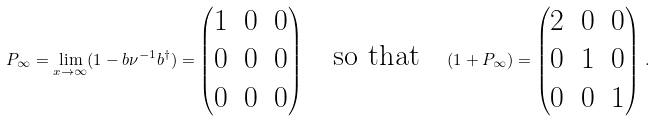<formula> <loc_0><loc_0><loc_500><loc_500>P _ { \infty } = \lim _ { x \rightarrow \infty } ( 1 - b \nu ^ { - 1 } b ^ { \dagger } ) = \begin{pmatrix} 1 & 0 & 0 \\ 0 & 0 & 0 \\ 0 & 0 & 0 \end{pmatrix} \quad \text {so that} \quad ( 1 + P _ { \infty } ) = \begin{pmatrix} 2 & 0 & 0 \\ 0 & 1 & 0 \\ 0 & 0 & 1 \end{pmatrix} \, .</formula> 